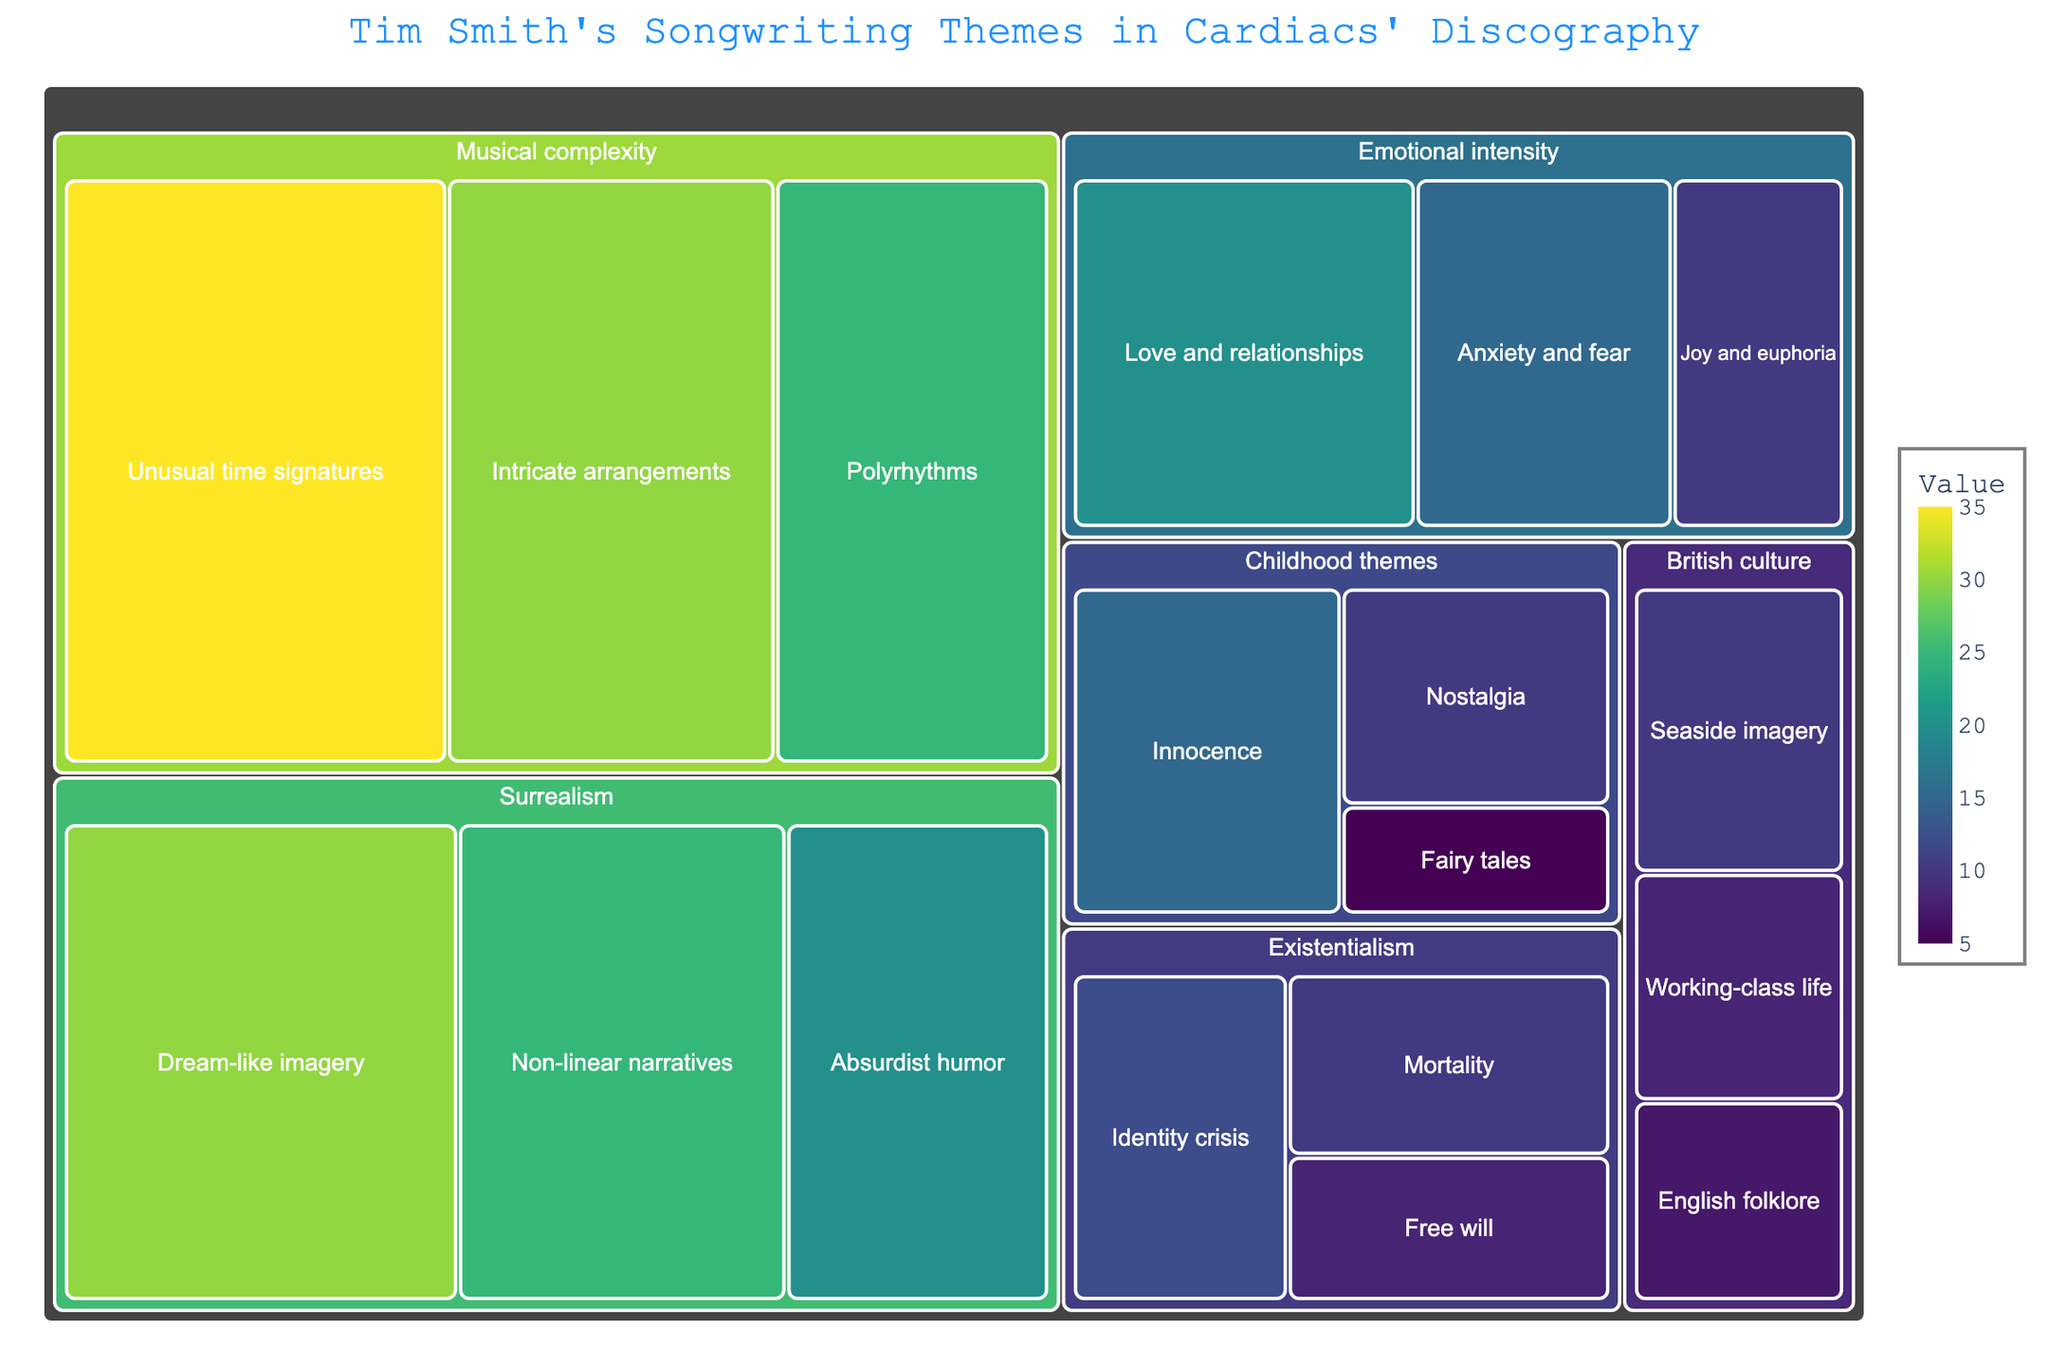What is the primary theme with the highest value in the treemap? The primary themes are categorized, and each theme is represented by a section with subdivisions. The largest section on the treemap, indicated by its size and value, is 'Musical complexity' with the highest value of 35 for 'Unusual time signatures'.
Answer: Musical complexity How many subcategories are there under the 'Surrealism' theme? The 'Surrealism' theme is subdivided into distinct subcategories, each represented by smaller sections within the 'Surrealism' block. By counting these subdivisions, we can see there are three subcategories: 'Dream-like imagery', 'Non-linear narratives', and 'Absurdist humor'.
Answer: 3 Which subcategory within 'Emotional intensity' has the smallest value? By locating the 'Emotional intensity' theme and examining its subcategories, we can see the values corresponding to each. The smallest value among 'Love and relationships', 'Anxiety and fear', and 'Joy and euphoria' is 10 for 'Joy and euphoria'.
Answer: Joy and euphoria What is the combined value of all subcategories under 'British culture'? To find the combined value, add the individual values of all subcategories under 'British culture': 'Seaside imagery' (10), 'Working-class life' (8), and 'English folklore' (7). The sum of these values is 10 + 8 + 7 = 25.
Answer: 25 Compare the total values of the 'Surrealism' and 'Existentialism' categories. Which one is larger, and by how much? Calculate the total values for each category by summing the values of their subcategories. For 'Surrealism', the sum is 30 (Dream-like imagery) + 25 (Non-linear narratives) + 20 (Absurdist humor) = 75. For 'Existentialism', the sum is 12 (Identity crisis) + 10 (Mortality) + 8 (Free will) = 30. The difference is 75 - 30 = 45. 'Surrealism' is larger by 45.
Answer: Surrealism, by 45 Which subcategory has the highest value in the entire treemap? By examining all the subcategories across different themes, we identify 'Unusual time signatures' under 'Musical complexity' as having the highest individual value of 35.
Answer: Unusual time signatures What is the average value of subcategories under 'Childhood themes'? There are three subcategories under 'Childhood themes': 'Innocence' (15), 'Nostalgia' (10), and 'Fairy tales' (5). Calculate the average by summing these values (15 + 10 + 5 = 30) and dividing by the number of subcategories (3). The average value is 30 / 3 = 10.
Answer: 10 How does the total value of 'Musical complexity' compare to the cumulative value of 'Emotional intensity' and 'Childhood themes'? First, find the total value of 'Musical complexity' by adding its subcategories: 'Unusual time signatures' (35), 'Intricate arrangements' (30), and 'Polyrhythms' (25). This equals 90. Then, sum the values for 'Emotional intensity' (20 + 15 + 10 = 45) and 'Childhood themes' (15 + 10 + 5 = 30), resulting in a combined total of 75. The 'Musical complexity' total is 90 - 75 = 15 greater.
Answer: Musical complexity, by 15 Which two subcategories under any primary theme have the closest values? Compare the values of all subcategories and find the pairs with the smallest difference. The closest values are 'Working-class life' (8) and 'Free will' (8), both having identical values under their respective themes.
Answer: Working-class life and Free will What proportion of the total value does the 'Surrealism' theme represent? First, determine the sum of all values in the data, which is the sum of the values across all subcategories: 30 + 25 + 20 + 35 + 30 + 25 + 20 + 15 + 10 + 15 + 10 + 5 + 10 + 8 + 7 + 12 + 10 + 8 = 315. The total for 'Surrealism' is 75 as previously calculated. The proportion is 75 / 315.
Answer: Approximately 0.238, or 23.8% 